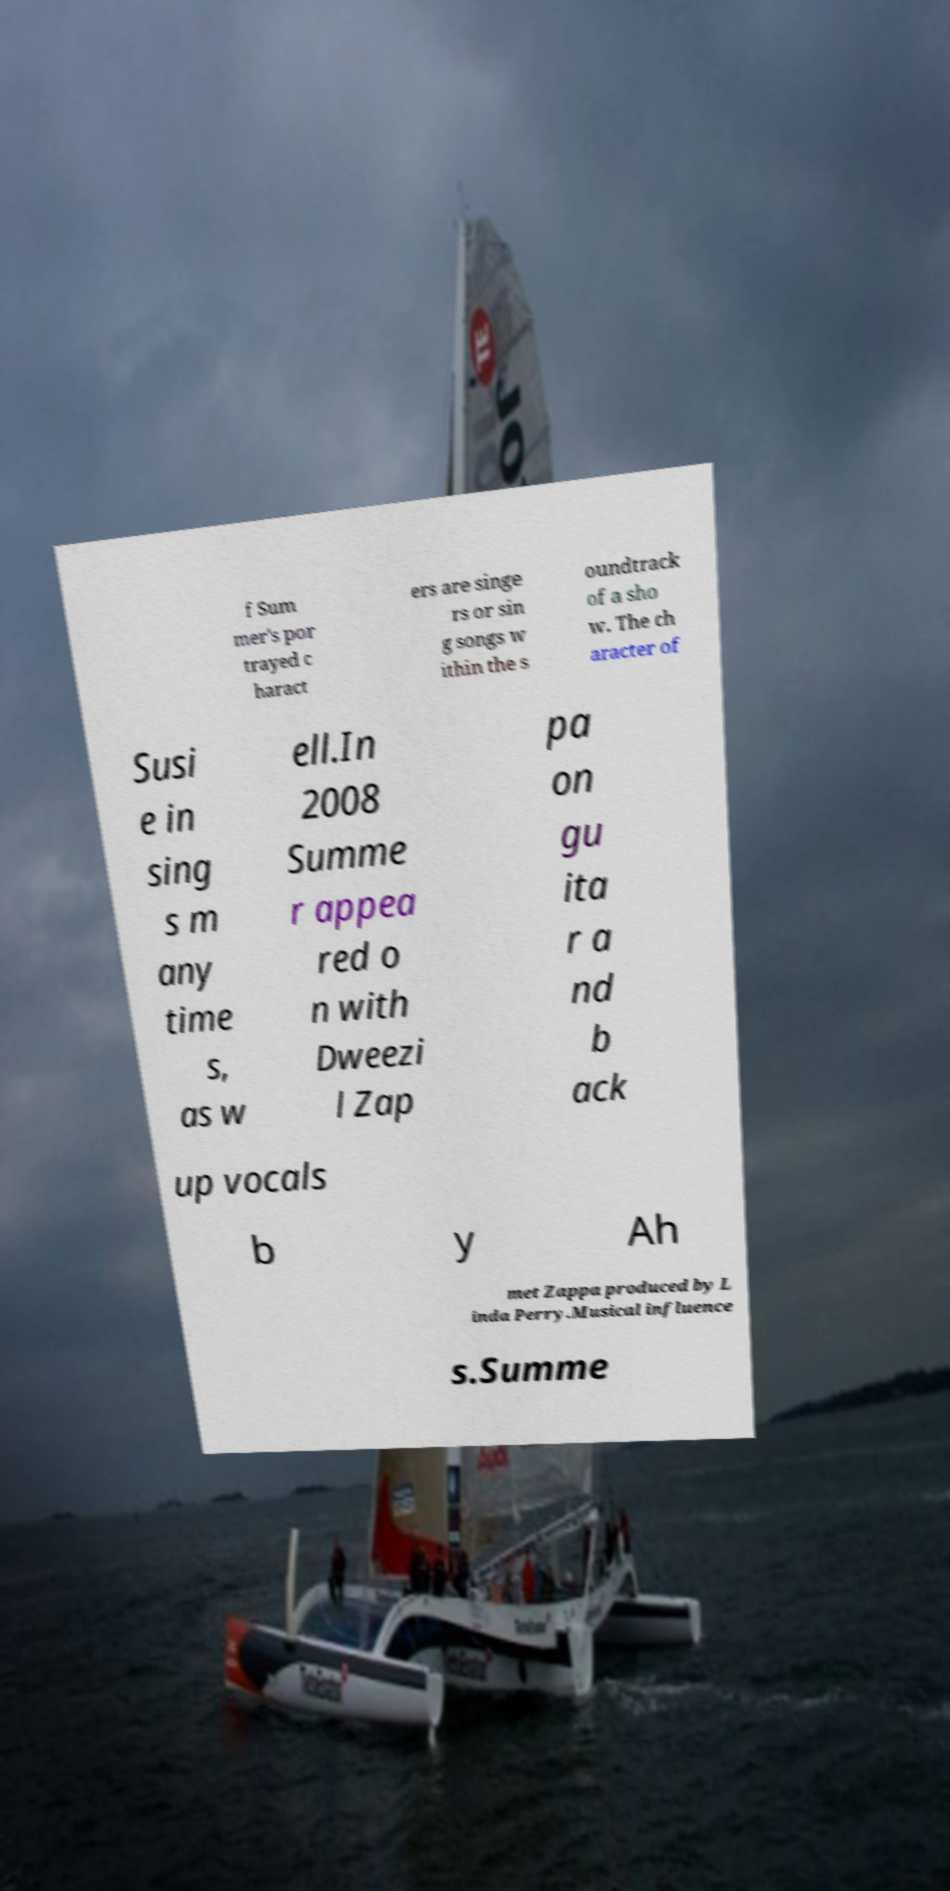Can you read and provide the text displayed in the image?This photo seems to have some interesting text. Can you extract and type it out for me? f Sum mer's por trayed c haract ers are singe rs or sin g songs w ithin the s oundtrack of a sho w. The ch aracter of Susi e in sing s m any time s, as w ell.In 2008 Summe r appea red o n with Dweezi l Zap pa on gu ita r a nd b ack up vocals b y Ah met Zappa produced by L inda Perry.Musical influence s.Summe 